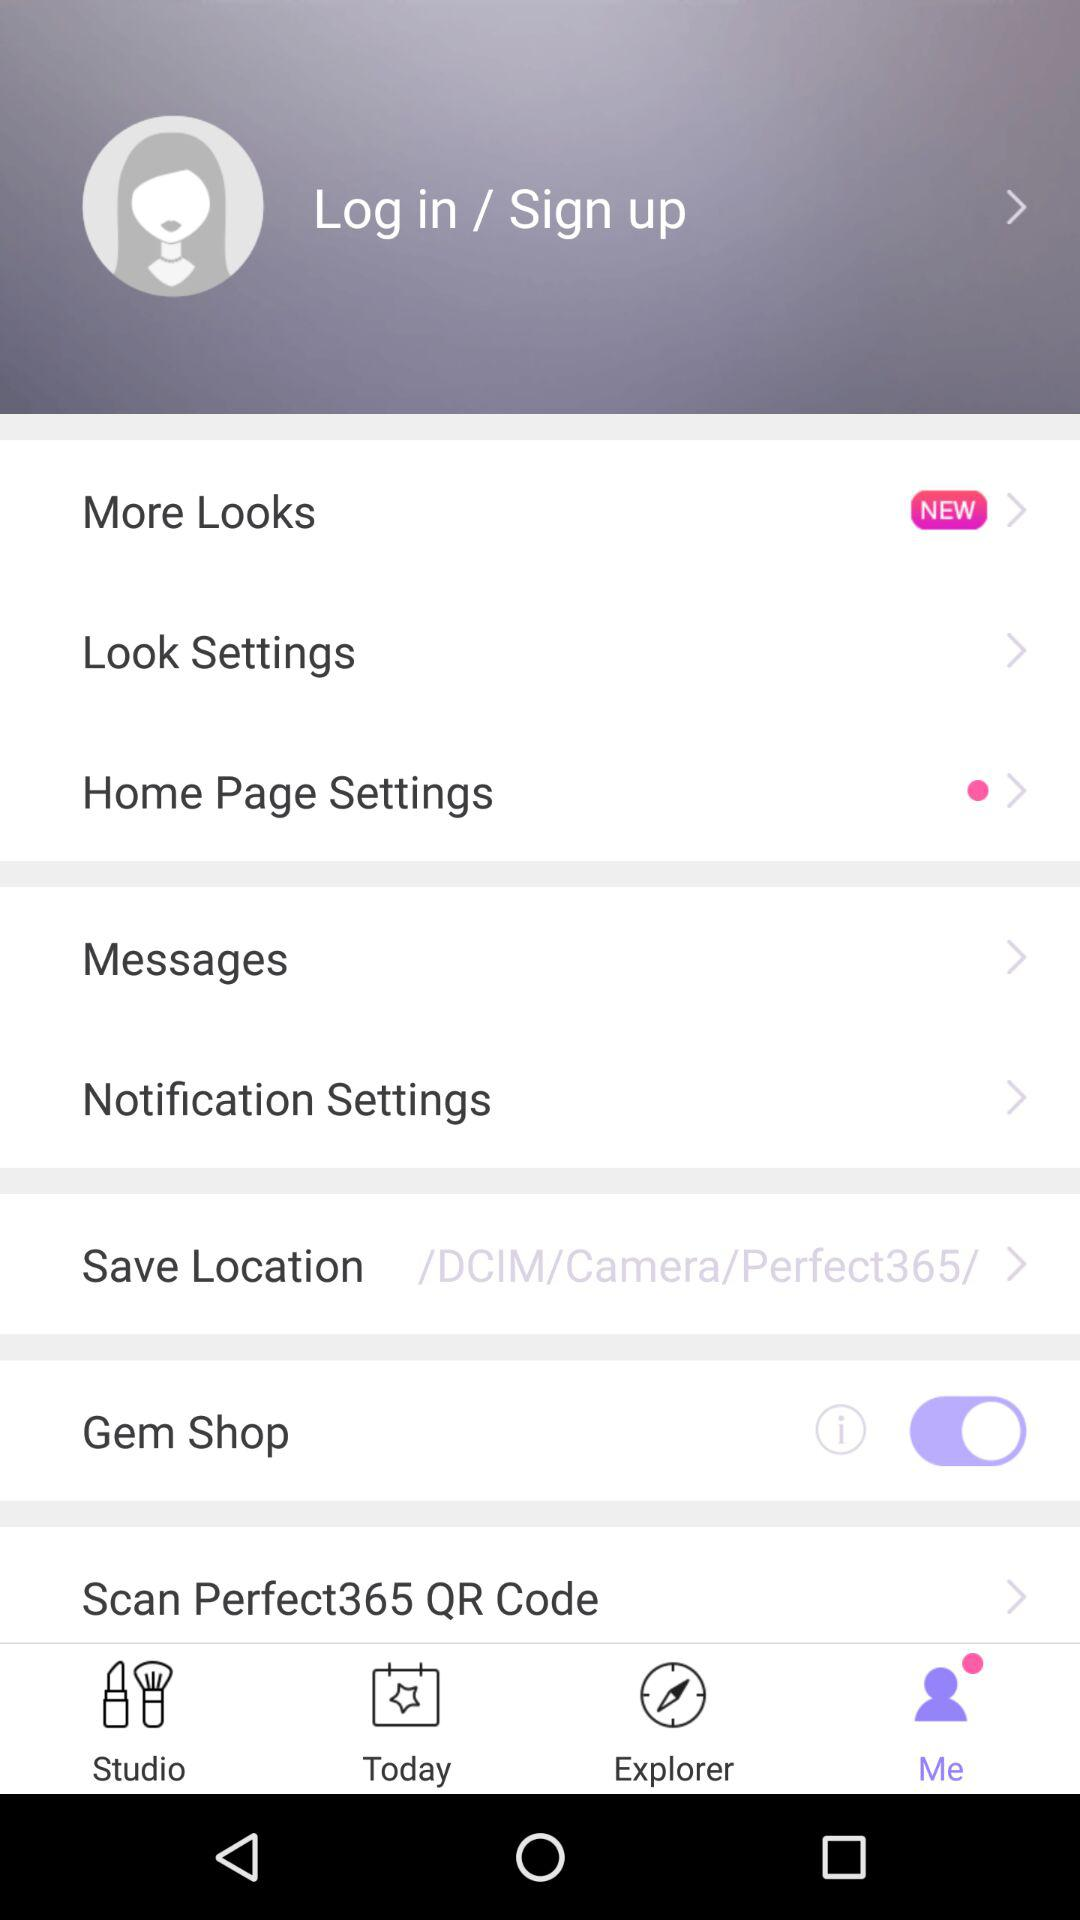What is the status of "Gem Shop"? The status of "Gem Shop" is "on". 